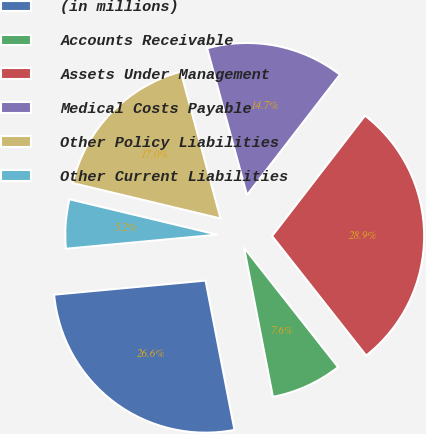Convert chart. <chart><loc_0><loc_0><loc_500><loc_500><pie_chart><fcel>(in millions)<fcel>Accounts Receivable<fcel>Assets Under Management<fcel>Medical Costs Payable<fcel>Other Policy Liabilities<fcel>Other Current Liabilities<nl><fcel>26.57%<fcel>7.57%<fcel>28.93%<fcel>14.68%<fcel>17.04%<fcel>5.22%<nl></chart> 